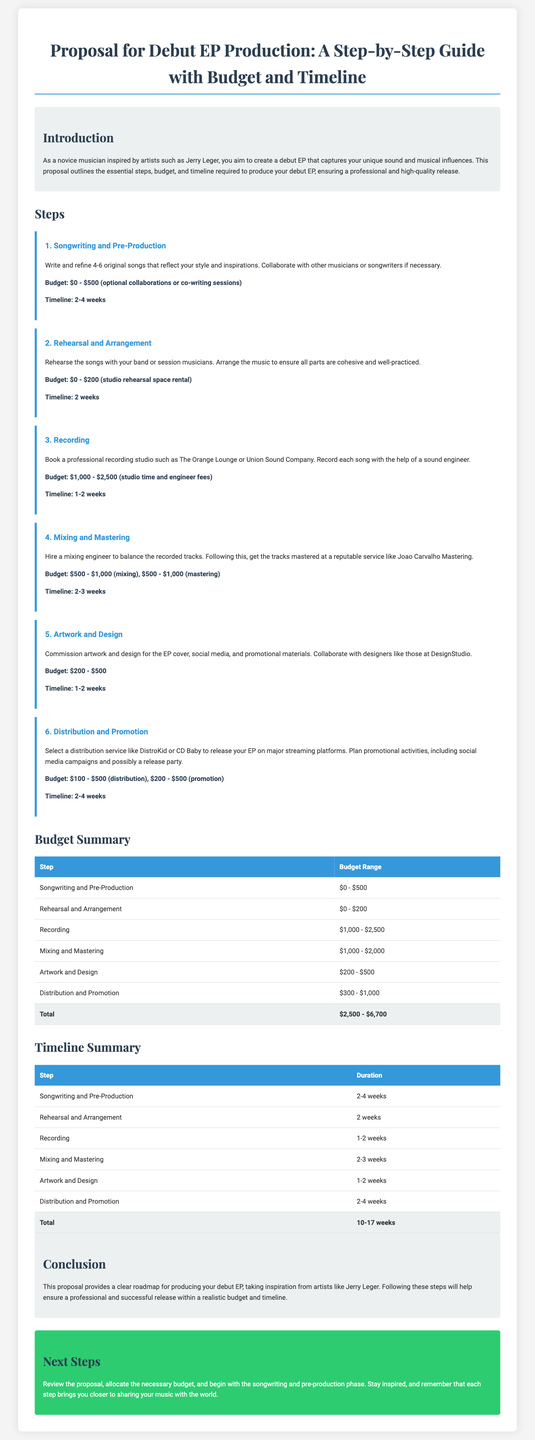What is the budget range for recording? The budget range for recording is detailed in the step "Recording" which states the costs involved.
Answer: $1,000 - $2,500 What is the timeline for mixing and mastering? The timeline for mixing and mastering is indicated in the corresponding step, which explains the duration needed for this process.
Answer: 2-3 weeks How many songs are to be written in the songwriting phase? The proposal specifies the quantity of original songs to be written in the songwriting and pre-production step.
Answer: 4-6 What is the maximum total budget for the EP production? The total budget is derived from summing up the highest ranges of the budget for each step in the proposal.
Answer: $6,700 How long is the estimated overall timeline for producing the EP? The overall timeline is calculated based on all individual steps' durations presented in the timeline summary.
Answer: 10-17 weeks What type of artwork is commissioned for the EP? The section on Artwork and Design identifies the type of materials to be created and who collaborates on them.
Answer: EP cover, social media, and promotional materials Which service is recommended for EP distribution? The document lists suggested distribution services under the distribution and promotion step, confirming recommendations for this phase.
Answer: DistroKid or CD Baby What is the first step in the production process? The initial step is explicitly stated at the beginning of the steps section outlining the first phase following the introduction.
Answer: Songwriting and Pre-Production What design style is the document implemented in? The document establishes the overall aesthetic and text styles intended for presentation and ease of reading.
Answer: Modern and clean design 